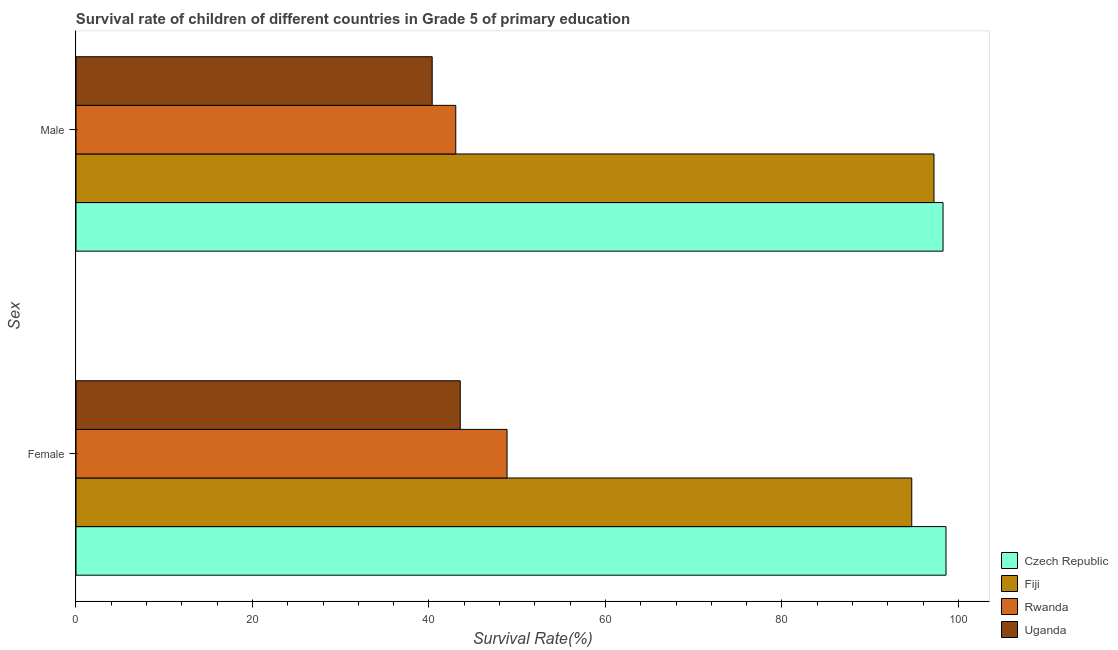What is the survival rate of female students in primary education in Fiji?
Make the answer very short. 94.71. Across all countries, what is the maximum survival rate of female students in primary education?
Make the answer very short. 98.59. Across all countries, what is the minimum survival rate of male students in primary education?
Offer a terse response. 40.36. In which country was the survival rate of male students in primary education maximum?
Keep it short and to the point. Czech Republic. In which country was the survival rate of male students in primary education minimum?
Give a very brief answer. Uganda. What is the total survival rate of female students in primary education in the graph?
Provide a succinct answer. 285.68. What is the difference between the survival rate of male students in primary education in Uganda and that in Czech Republic?
Provide a succinct answer. -57.89. What is the difference between the survival rate of male students in primary education in Fiji and the survival rate of female students in primary education in Rwanda?
Offer a very short reply. 48.38. What is the average survival rate of male students in primary education per country?
Ensure brevity in your answer.  69.72. What is the difference between the survival rate of female students in primary education and survival rate of male students in primary education in Fiji?
Provide a succinct answer. -2.52. In how many countries, is the survival rate of male students in primary education greater than 64 %?
Give a very brief answer. 2. What is the ratio of the survival rate of male students in primary education in Uganda to that in Rwanda?
Offer a terse response. 0.94. What does the 3rd bar from the top in Male represents?
Provide a short and direct response. Fiji. What does the 3rd bar from the bottom in Female represents?
Offer a very short reply. Rwanda. How many bars are there?
Offer a terse response. 8. Does the graph contain grids?
Make the answer very short. No. How many legend labels are there?
Keep it short and to the point. 4. How are the legend labels stacked?
Your answer should be compact. Vertical. What is the title of the graph?
Your answer should be compact. Survival rate of children of different countries in Grade 5 of primary education. Does "Middle income" appear as one of the legend labels in the graph?
Ensure brevity in your answer.  No. What is the label or title of the X-axis?
Offer a terse response. Survival Rate(%). What is the label or title of the Y-axis?
Give a very brief answer. Sex. What is the Survival Rate(%) in Czech Republic in Female?
Your response must be concise. 98.59. What is the Survival Rate(%) of Fiji in Female?
Make the answer very short. 94.71. What is the Survival Rate(%) of Rwanda in Female?
Ensure brevity in your answer.  48.85. What is the Survival Rate(%) in Uganda in Female?
Keep it short and to the point. 43.54. What is the Survival Rate(%) in Czech Republic in Male?
Provide a short and direct response. 98.25. What is the Survival Rate(%) of Fiji in Male?
Ensure brevity in your answer.  97.22. What is the Survival Rate(%) of Rwanda in Male?
Offer a terse response. 43.03. What is the Survival Rate(%) of Uganda in Male?
Offer a terse response. 40.36. Across all Sex, what is the maximum Survival Rate(%) in Czech Republic?
Ensure brevity in your answer.  98.59. Across all Sex, what is the maximum Survival Rate(%) in Fiji?
Give a very brief answer. 97.22. Across all Sex, what is the maximum Survival Rate(%) of Rwanda?
Your answer should be very brief. 48.85. Across all Sex, what is the maximum Survival Rate(%) in Uganda?
Provide a succinct answer. 43.54. Across all Sex, what is the minimum Survival Rate(%) in Czech Republic?
Provide a short and direct response. 98.25. Across all Sex, what is the minimum Survival Rate(%) of Fiji?
Provide a succinct answer. 94.71. Across all Sex, what is the minimum Survival Rate(%) of Rwanda?
Keep it short and to the point. 43.03. Across all Sex, what is the minimum Survival Rate(%) of Uganda?
Provide a short and direct response. 40.36. What is the total Survival Rate(%) in Czech Republic in the graph?
Offer a very short reply. 196.84. What is the total Survival Rate(%) in Fiji in the graph?
Your answer should be very brief. 191.93. What is the total Survival Rate(%) in Rwanda in the graph?
Your answer should be very brief. 91.88. What is the total Survival Rate(%) in Uganda in the graph?
Keep it short and to the point. 83.91. What is the difference between the Survival Rate(%) of Czech Republic in Female and that in Male?
Provide a succinct answer. 0.34. What is the difference between the Survival Rate(%) in Fiji in Female and that in Male?
Your answer should be very brief. -2.52. What is the difference between the Survival Rate(%) of Rwanda in Female and that in Male?
Your answer should be very brief. 5.81. What is the difference between the Survival Rate(%) in Uganda in Female and that in Male?
Give a very brief answer. 3.18. What is the difference between the Survival Rate(%) in Czech Republic in Female and the Survival Rate(%) in Fiji in Male?
Keep it short and to the point. 1.36. What is the difference between the Survival Rate(%) of Czech Republic in Female and the Survival Rate(%) of Rwanda in Male?
Offer a very short reply. 55.55. What is the difference between the Survival Rate(%) of Czech Republic in Female and the Survival Rate(%) of Uganda in Male?
Provide a succinct answer. 58.22. What is the difference between the Survival Rate(%) of Fiji in Female and the Survival Rate(%) of Rwanda in Male?
Provide a succinct answer. 51.67. What is the difference between the Survival Rate(%) of Fiji in Female and the Survival Rate(%) of Uganda in Male?
Offer a very short reply. 54.34. What is the difference between the Survival Rate(%) in Rwanda in Female and the Survival Rate(%) in Uganda in Male?
Keep it short and to the point. 8.48. What is the average Survival Rate(%) in Czech Republic per Sex?
Provide a short and direct response. 98.42. What is the average Survival Rate(%) in Fiji per Sex?
Offer a very short reply. 95.97. What is the average Survival Rate(%) of Rwanda per Sex?
Provide a short and direct response. 45.94. What is the average Survival Rate(%) of Uganda per Sex?
Your answer should be very brief. 41.95. What is the difference between the Survival Rate(%) in Czech Republic and Survival Rate(%) in Fiji in Female?
Give a very brief answer. 3.88. What is the difference between the Survival Rate(%) in Czech Republic and Survival Rate(%) in Rwanda in Female?
Give a very brief answer. 49.74. What is the difference between the Survival Rate(%) of Czech Republic and Survival Rate(%) of Uganda in Female?
Offer a terse response. 55.04. What is the difference between the Survival Rate(%) of Fiji and Survival Rate(%) of Rwanda in Female?
Provide a succinct answer. 45.86. What is the difference between the Survival Rate(%) in Fiji and Survival Rate(%) in Uganda in Female?
Offer a very short reply. 51.16. What is the difference between the Survival Rate(%) of Rwanda and Survival Rate(%) of Uganda in Female?
Give a very brief answer. 5.3. What is the difference between the Survival Rate(%) in Czech Republic and Survival Rate(%) in Fiji in Male?
Your answer should be very brief. 1.03. What is the difference between the Survival Rate(%) in Czech Republic and Survival Rate(%) in Rwanda in Male?
Provide a succinct answer. 55.22. What is the difference between the Survival Rate(%) of Czech Republic and Survival Rate(%) of Uganda in Male?
Your response must be concise. 57.89. What is the difference between the Survival Rate(%) in Fiji and Survival Rate(%) in Rwanda in Male?
Make the answer very short. 54.19. What is the difference between the Survival Rate(%) in Fiji and Survival Rate(%) in Uganda in Male?
Offer a terse response. 56.86. What is the difference between the Survival Rate(%) of Rwanda and Survival Rate(%) of Uganda in Male?
Keep it short and to the point. 2.67. What is the ratio of the Survival Rate(%) of Fiji in Female to that in Male?
Provide a short and direct response. 0.97. What is the ratio of the Survival Rate(%) in Rwanda in Female to that in Male?
Provide a short and direct response. 1.14. What is the ratio of the Survival Rate(%) in Uganda in Female to that in Male?
Provide a succinct answer. 1.08. What is the difference between the highest and the second highest Survival Rate(%) of Czech Republic?
Your response must be concise. 0.34. What is the difference between the highest and the second highest Survival Rate(%) of Fiji?
Ensure brevity in your answer.  2.52. What is the difference between the highest and the second highest Survival Rate(%) of Rwanda?
Your answer should be compact. 5.81. What is the difference between the highest and the second highest Survival Rate(%) in Uganda?
Give a very brief answer. 3.18. What is the difference between the highest and the lowest Survival Rate(%) of Czech Republic?
Provide a short and direct response. 0.34. What is the difference between the highest and the lowest Survival Rate(%) in Fiji?
Give a very brief answer. 2.52. What is the difference between the highest and the lowest Survival Rate(%) in Rwanda?
Your answer should be very brief. 5.81. What is the difference between the highest and the lowest Survival Rate(%) of Uganda?
Provide a succinct answer. 3.18. 